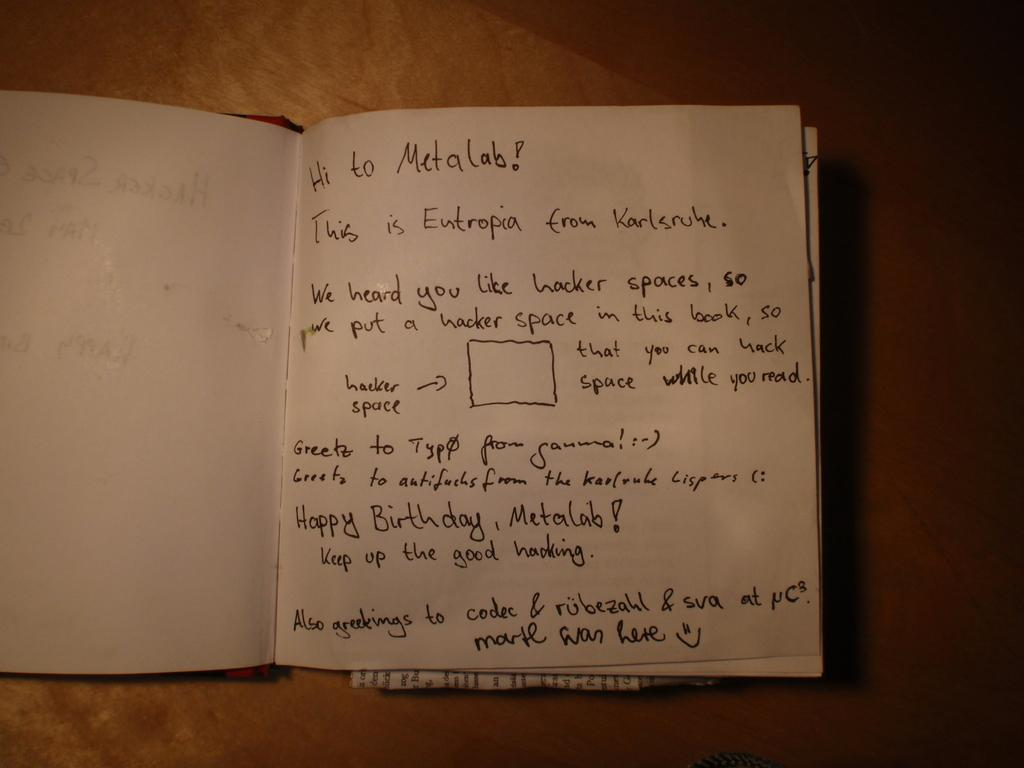<image>
Give a short and clear explanation of the subsequent image. Textbook that is saying happy birthday to the Metalab. 